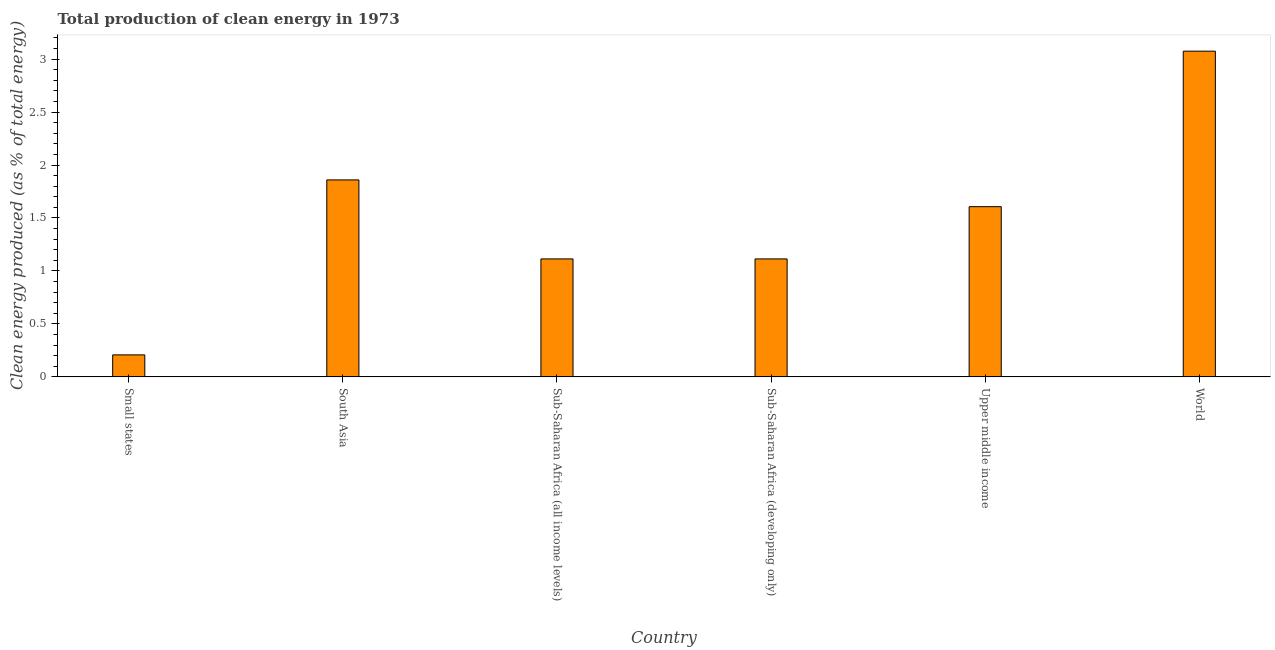Does the graph contain any zero values?
Your answer should be compact. No. What is the title of the graph?
Make the answer very short. Total production of clean energy in 1973. What is the label or title of the Y-axis?
Your answer should be very brief. Clean energy produced (as % of total energy). What is the production of clean energy in Upper middle income?
Your answer should be compact. 1.61. Across all countries, what is the maximum production of clean energy?
Your answer should be very brief. 3.07. Across all countries, what is the minimum production of clean energy?
Ensure brevity in your answer.  0.21. In which country was the production of clean energy maximum?
Keep it short and to the point. World. In which country was the production of clean energy minimum?
Give a very brief answer. Small states. What is the sum of the production of clean energy?
Offer a very short reply. 8.98. What is the difference between the production of clean energy in Small states and South Asia?
Give a very brief answer. -1.65. What is the average production of clean energy per country?
Offer a terse response. 1.5. What is the median production of clean energy?
Your answer should be very brief. 1.36. What is the ratio of the production of clean energy in Sub-Saharan Africa (all income levels) to that in World?
Ensure brevity in your answer.  0.36. What is the difference between the highest and the second highest production of clean energy?
Your answer should be very brief. 1.22. Is the sum of the production of clean energy in Upper middle income and World greater than the maximum production of clean energy across all countries?
Offer a very short reply. Yes. What is the difference between the highest and the lowest production of clean energy?
Keep it short and to the point. 2.87. In how many countries, is the production of clean energy greater than the average production of clean energy taken over all countries?
Provide a short and direct response. 3. How many bars are there?
Keep it short and to the point. 6. Are all the bars in the graph horizontal?
Your response must be concise. No. Are the values on the major ticks of Y-axis written in scientific E-notation?
Ensure brevity in your answer.  No. What is the Clean energy produced (as % of total energy) of Small states?
Your answer should be compact. 0.21. What is the Clean energy produced (as % of total energy) in South Asia?
Your response must be concise. 1.86. What is the Clean energy produced (as % of total energy) in Sub-Saharan Africa (all income levels)?
Your response must be concise. 1.11. What is the Clean energy produced (as % of total energy) in Sub-Saharan Africa (developing only)?
Give a very brief answer. 1.11. What is the Clean energy produced (as % of total energy) in Upper middle income?
Make the answer very short. 1.61. What is the Clean energy produced (as % of total energy) of World?
Keep it short and to the point. 3.07. What is the difference between the Clean energy produced (as % of total energy) in Small states and South Asia?
Give a very brief answer. -1.65. What is the difference between the Clean energy produced (as % of total energy) in Small states and Sub-Saharan Africa (all income levels)?
Offer a terse response. -0.91. What is the difference between the Clean energy produced (as % of total energy) in Small states and Sub-Saharan Africa (developing only)?
Ensure brevity in your answer.  -0.91. What is the difference between the Clean energy produced (as % of total energy) in Small states and Upper middle income?
Keep it short and to the point. -1.4. What is the difference between the Clean energy produced (as % of total energy) in Small states and World?
Keep it short and to the point. -2.87. What is the difference between the Clean energy produced (as % of total energy) in South Asia and Sub-Saharan Africa (all income levels)?
Make the answer very short. 0.75. What is the difference between the Clean energy produced (as % of total energy) in South Asia and Sub-Saharan Africa (developing only)?
Your answer should be very brief. 0.75. What is the difference between the Clean energy produced (as % of total energy) in South Asia and Upper middle income?
Provide a short and direct response. 0.25. What is the difference between the Clean energy produced (as % of total energy) in South Asia and World?
Offer a very short reply. -1.22. What is the difference between the Clean energy produced (as % of total energy) in Sub-Saharan Africa (all income levels) and Upper middle income?
Offer a terse response. -0.49. What is the difference between the Clean energy produced (as % of total energy) in Sub-Saharan Africa (all income levels) and World?
Provide a short and direct response. -1.96. What is the difference between the Clean energy produced (as % of total energy) in Sub-Saharan Africa (developing only) and Upper middle income?
Provide a short and direct response. -0.49. What is the difference between the Clean energy produced (as % of total energy) in Sub-Saharan Africa (developing only) and World?
Give a very brief answer. -1.96. What is the difference between the Clean energy produced (as % of total energy) in Upper middle income and World?
Ensure brevity in your answer.  -1.47. What is the ratio of the Clean energy produced (as % of total energy) in Small states to that in South Asia?
Give a very brief answer. 0.11. What is the ratio of the Clean energy produced (as % of total energy) in Small states to that in Sub-Saharan Africa (all income levels)?
Make the answer very short. 0.19. What is the ratio of the Clean energy produced (as % of total energy) in Small states to that in Sub-Saharan Africa (developing only)?
Ensure brevity in your answer.  0.19. What is the ratio of the Clean energy produced (as % of total energy) in Small states to that in Upper middle income?
Ensure brevity in your answer.  0.13. What is the ratio of the Clean energy produced (as % of total energy) in Small states to that in World?
Your answer should be compact. 0.07. What is the ratio of the Clean energy produced (as % of total energy) in South Asia to that in Sub-Saharan Africa (all income levels)?
Keep it short and to the point. 1.67. What is the ratio of the Clean energy produced (as % of total energy) in South Asia to that in Sub-Saharan Africa (developing only)?
Keep it short and to the point. 1.67. What is the ratio of the Clean energy produced (as % of total energy) in South Asia to that in Upper middle income?
Ensure brevity in your answer.  1.16. What is the ratio of the Clean energy produced (as % of total energy) in South Asia to that in World?
Keep it short and to the point. 0.6. What is the ratio of the Clean energy produced (as % of total energy) in Sub-Saharan Africa (all income levels) to that in Sub-Saharan Africa (developing only)?
Your answer should be compact. 1. What is the ratio of the Clean energy produced (as % of total energy) in Sub-Saharan Africa (all income levels) to that in Upper middle income?
Your answer should be very brief. 0.69. What is the ratio of the Clean energy produced (as % of total energy) in Sub-Saharan Africa (all income levels) to that in World?
Offer a very short reply. 0.36. What is the ratio of the Clean energy produced (as % of total energy) in Sub-Saharan Africa (developing only) to that in Upper middle income?
Your answer should be compact. 0.69. What is the ratio of the Clean energy produced (as % of total energy) in Sub-Saharan Africa (developing only) to that in World?
Provide a short and direct response. 0.36. What is the ratio of the Clean energy produced (as % of total energy) in Upper middle income to that in World?
Your answer should be very brief. 0.52. 